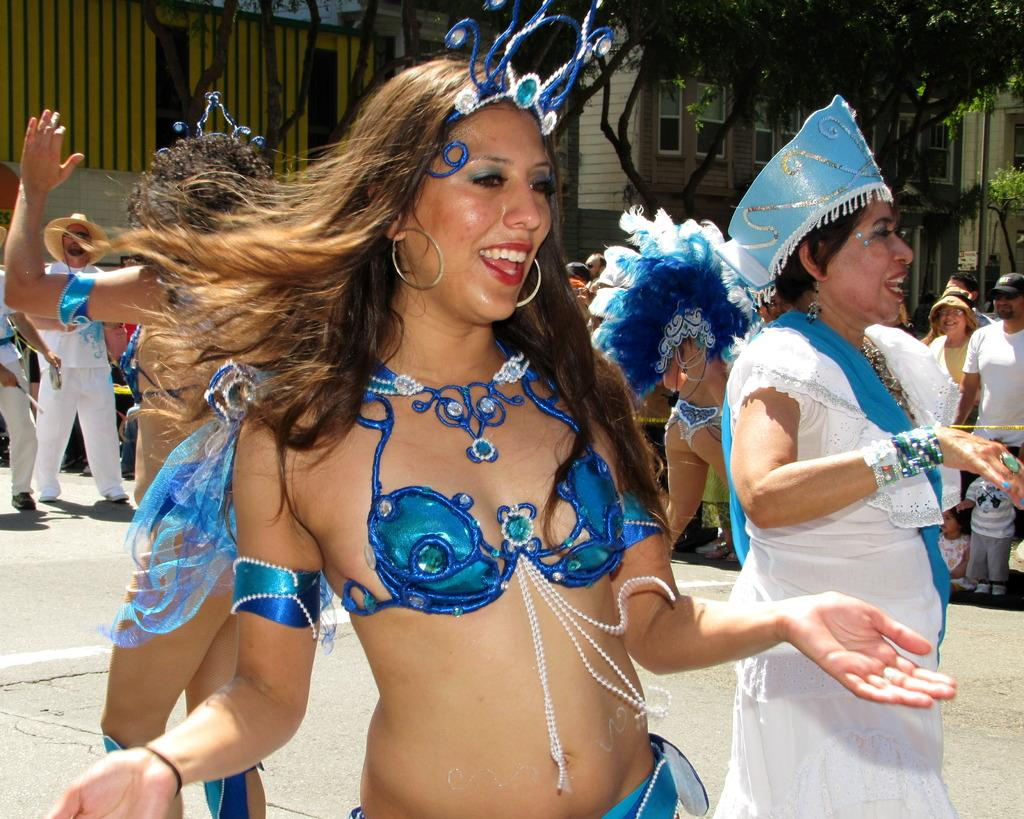What are the people in the image doing? There are people dancing on the road in the image. Are there any other people in the image besides the dancers? Yes, there are people walking behind the dancers. What can be seen in the background of the image? There are spectators, buildings, and trees in the background of the image. How many cattle can be seen grazing in the background of the image? There are no cattle present in the image; it features people dancing on the road and spectators in the background. 